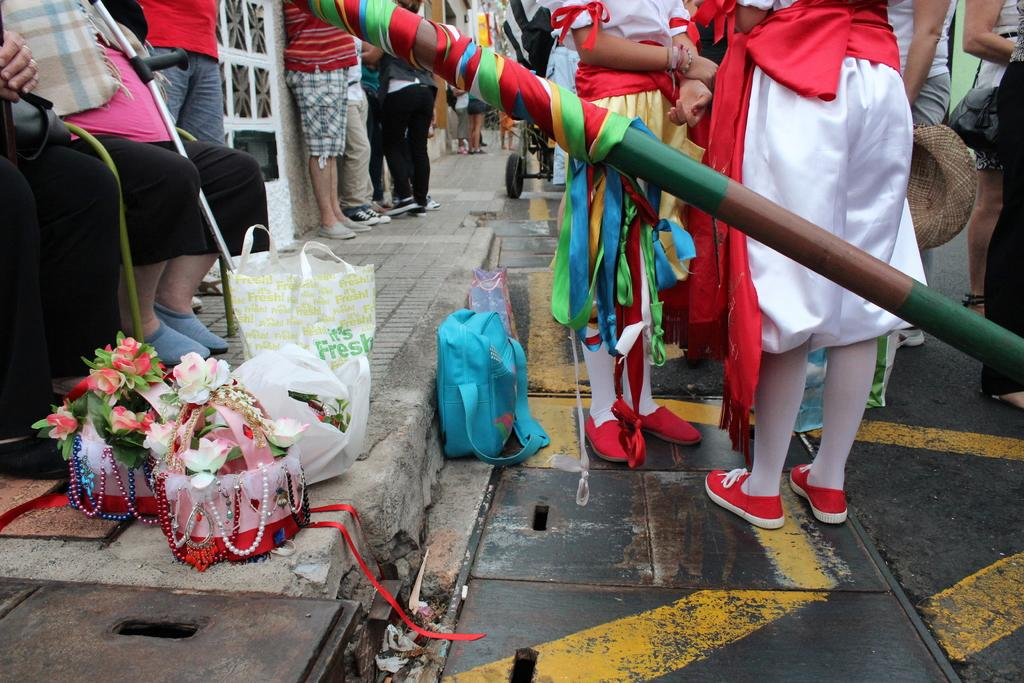What are the people in the image doing? The people in the image are standing on a pavement and sitting on a wall. Can you describe the objects on the footpath? Unfortunately, the provided facts do not give any information about the objects on the footpath. How many people are sitting on the wall? The provided facts do not specify the number of people sitting on the wall. Are there any icicles hanging from the wall in the image? There is no mention of icicles in the provided facts, so we cannot determine if they are present in the image. What thoughts are going through the people's minds in the image? The provided facts do not give any information about the people's thoughts or mental states. Are there any horses visible in the image? There is no mention of horses in the provided facts, so we cannot determine if they are present in the image. 